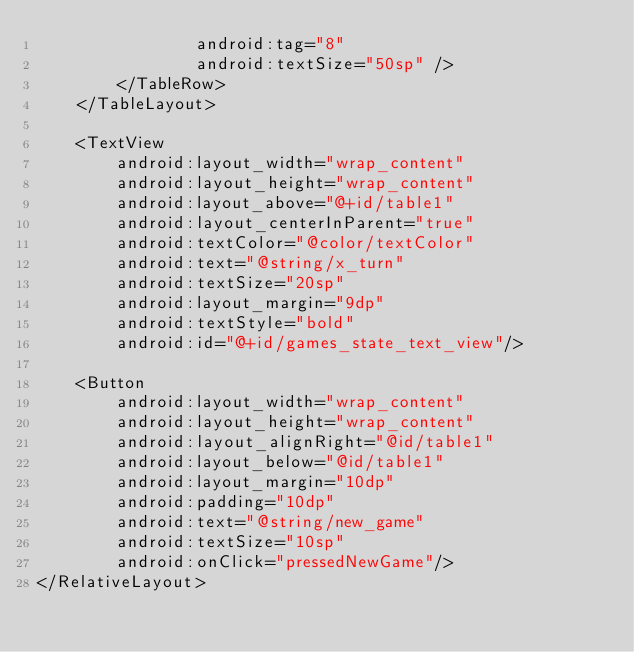<code> <loc_0><loc_0><loc_500><loc_500><_XML_>                android:tag="8"
                android:textSize="50sp" />
        </TableRow>
    </TableLayout>

    <TextView
        android:layout_width="wrap_content"
        android:layout_height="wrap_content"
        android:layout_above="@+id/table1"
        android:layout_centerInParent="true"
        android:textColor="@color/textColor"
        android:text="@string/x_turn"
        android:textSize="20sp"
        android:layout_margin="9dp"
        android:textStyle="bold"
        android:id="@+id/games_state_text_view"/>

    <Button
        android:layout_width="wrap_content"
        android:layout_height="wrap_content"
        android:layout_alignRight="@id/table1"
        android:layout_below="@id/table1"
        android:layout_margin="10dp"
        android:padding="10dp"
        android:text="@string/new_game"
        android:textSize="10sp"
        android:onClick="pressedNewGame"/>
</RelativeLayout></code> 